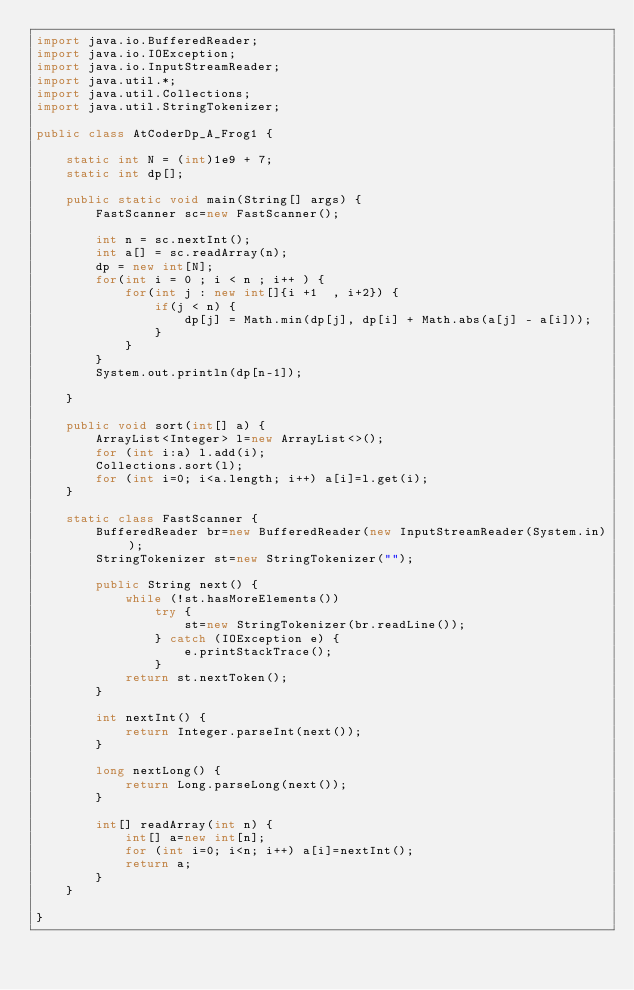<code> <loc_0><loc_0><loc_500><loc_500><_Java_>import java.io.BufferedReader;
import java.io.IOException;
import java.io.InputStreamReader;
import java.util.*;
import java.util.Collections;
import java.util.StringTokenizer;
 
public class AtCoderDp_A_Frog1 {
	
	static int N = (int)1e9 + 7;
	static int dp[];
 
	public static void main(String[] args) {
		FastScanner sc=new FastScanner();

		int n = sc.nextInt();
		int a[] = sc.readArray(n);
		dp = new int[N];
		for(int i = 0 ; i < n ; i++ ) {
			for(int j : new int[]{i +1  , i+2}) {
				if(j < n) {
					dp[j] = Math.min(dp[j], dp[i] + Math.abs(a[j] - a[i]));
				}
			}
		}
		System.out.println(dp[n-1]);
		
	}
	
	public void sort(int[] a) {
		ArrayList<Integer> l=new ArrayList<>();
		for (int i:a) l.add(i);
		Collections.sort(l);
		for (int i=0; i<a.length; i++) a[i]=l.get(i);
	}
	
	static class FastScanner {
		BufferedReader br=new BufferedReader(new InputStreamReader(System.in));
		StringTokenizer st=new StringTokenizer("");
		
		public String next() {
			while (!st.hasMoreElements())
				try {
					st=new StringTokenizer(br.readLine());
				} catch (IOException e) {
					e.printStackTrace();
				}
			return st.nextToken();
		}
		
		int nextInt() {
			return Integer.parseInt(next());
		}
		
		long nextLong() {
			return Long.parseLong(next());
		}
		
		int[] readArray(int n) {
			int[] a=new int[n];
			for (int i=0; i<n; i++) a[i]=nextInt();
			return a;
		}
	}
 
}
</code> 